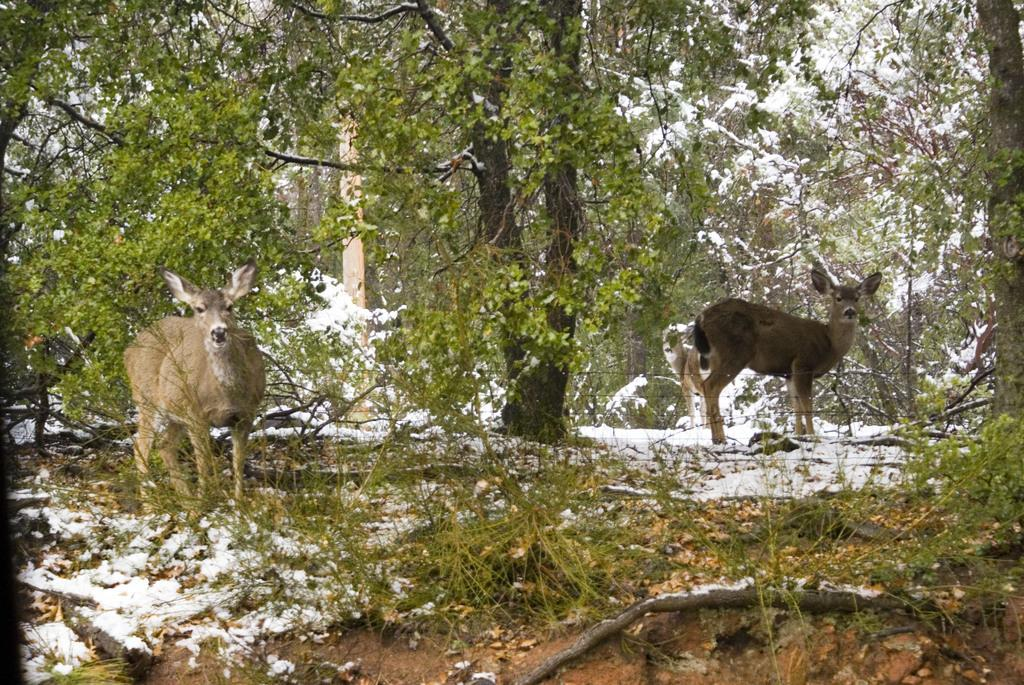What animals can be seen in the image? There are two deer in the image. What is the ground made of in the image? There is snow at the bottom of the image. What can be seen in the distance in the image? There are trees visible in the background of the image. Where is the nest located in the image? There is no nest present in the image. What type of throne can be seen in the image? There is no throne present in the image. 